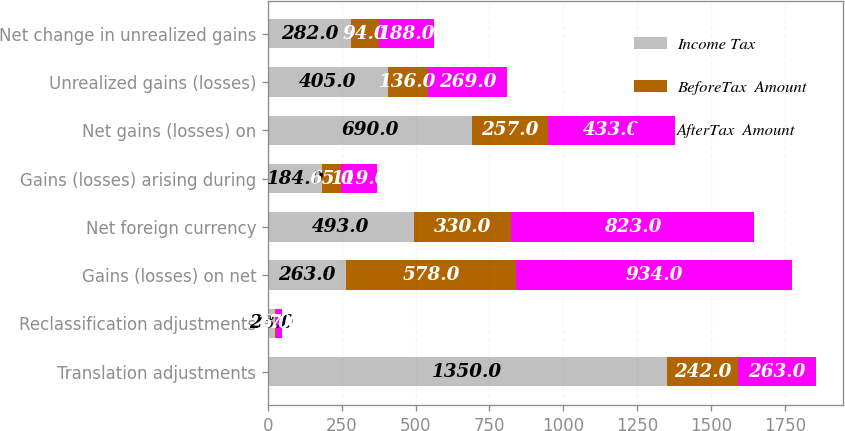Convert chart to OTSL. <chart><loc_0><loc_0><loc_500><loc_500><stacked_bar_chart><ecel><fcel>Translation adjustments<fcel>Reclassification adjustments<fcel>Gains (losses) on net<fcel>Net foreign currency<fcel>Gains (losses) arising during<fcel>Net gains (losses) on<fcel>Unrealized gains (losses)<fcel>Net change in unrealized gains<nl><fcel>Income Tax<fcel>1350<fcel>23<fcel>263<fcel>493<fcel>184<fcel>690<fcel>405<fcel>282<nl><fcel>BeforeTax  Amount<fcel>242<fcel>6<fcel>578<fcel>330<fcel>65<fcel>257<fcel>136<fcel>94<nl><fcel>AfterTax  Amount<fcel>263<fcel>17<fcel>934<fcel>823<fcel>119<fcel>433<fcel>269<fcel>188<nl></chart> 